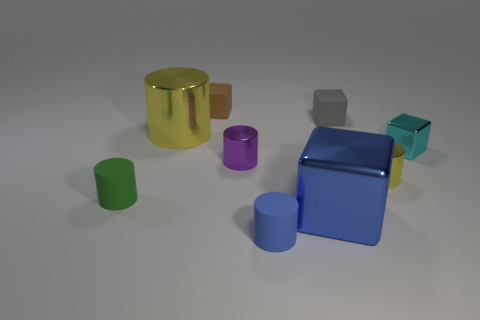Subtract all blue cylinders. How many cylinders are left? 4 Subtract all small purple metallic cylinders. How many cylinders are left? 4 Subtract all cyan cylinders. Subtract all yellow cubes. How many cylinders are left? 5 Subtract all blocks. How many objects are left? 5 Subtract 0 green spheres. How many objects are left? 9 Subtract all brown matte cubes. Subtract all small cyan metallic things. How many objects are left? 7 Add 1 small blue cylinders. How many small blue cylinders are left? 2 Add 2 brown cubes. How many brown cubes exist? 3 